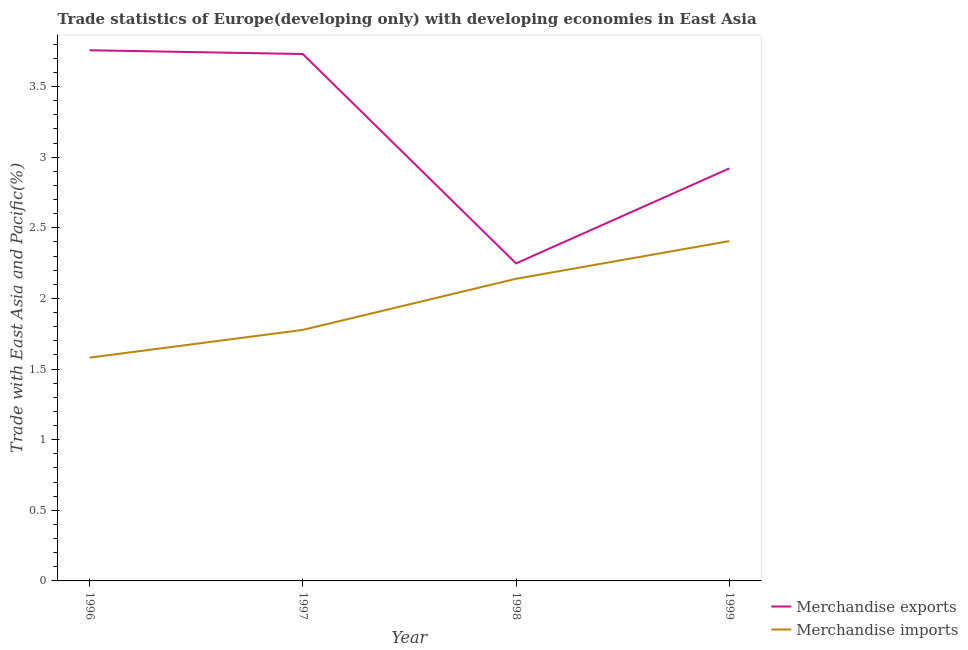Does the line corresponding to merchandise imports intersect with the line corresponding to merchandise exports?
Your answer should be compact. No. Is the number of lines equal to the number of legend labels?
Offer a very short reply. Yes. What is the merchandise exports in 1996?
Make the answer very short. 3.76. Across all years, what is the maximum merchandise exports?
Provide a succinct answer. 3.76. Across all years, what is the minimum merchandise imports?
Give a very brief answer. 1.58. In which year was the merchandise imports minimum?
Offer a very short reply. 1996. What is the total merchandise imports in the graph?
Make the answer very short. 7.9. What is the difference between the merchandise exports in 1998 and that in 1999?
Make the answer very short. -0.67. What is the difference between the merchandise imports in 1999 and the merchandise exports in 1996?
Offer a very short reply. -1.35. What is the average merchandise imports per year?
Give a very brief answer. 1.98. In the year 1996, what is the difference between the merchandise exports and merchandise imports?
Ensure brevity in your answer.  2.18. What is the ratio of the merchandise exports in 1996 to that in 1997?
Your response must be concise. 1.01. Is the merchandise imports in 1996 less than that in 1998?
Provide a succinct answer. Yes. Is the difference between the merchandise exports in 1996 and 1999 greater than the difference between the merchandise imports in 1996 and 1999?
Your answer should be compact. Yes. What is the difference between the highest and the second highest merchandise imports?
Your response must be concise. 0.27. What is the difference between the highest and the lowest merchandise exports?
Provide a succinct answer. 1.51. Does the merchandise exports monotonically increase over the years?
Offer a terse response. No. What is the difference between two consecutive major ticks on the Y-axis?
Make the answer very short. 0.5. Does the graph contain any zero values?
Make the answer very short. No. Does the graph contain grids?
Your answer should be very brief. No. Where does the legend appear in the graph?
Offer a terse response. Bottom right. How are the legend labels stacked?
Keep it short and to the point. Vertical. What is the title of the graph?
Offer a very short reply. Trade statistics of Europe(developing only) with developing economies in East Asia. What is the label or title of the X-axis?
Offer a terse response. Year. What is the label or title of the Y-axis?
Your response must be concise. Trade with East Asia and Pacific(%). What is the Trade with East Asia and Pacific(%) in Merchandise exports in 1996?
Your response must be concise. 3.76. What is the Trade with East Asia and Pacific(%) in Merchandise imports in 1996?
Provide a short and direct response. 1.58. What is the Trade with East Asia and Pacific(%) in Merchandise exports in 1997?
Ensure brevity in your answer.  3.73. What is the Trade with East Asia and Pacific(%) of Merchandise imports in 1997?
Your response must be concise. 1.78. What is the Trade with East Asia and Pacific(%) of Merchandise exports in 1998?
Offer a terse response. 2.25. What is the Trade with East Asia and Pacific(%) in Merchandise imports in 1998?
Provide a succinct answer. 2.14. What is the Trade with East Asia and Pacific(%) in Merchandise exports in 1999?
Offer a very short reply. 2.92. What is the Trade with East Asia and Pacific(%) of Merchandise imports in 1999?
Give a very brief answer. 2.41. Across all years, what is the maximum Trade with East Asia and Pacific(%) of Merchandise exports?
Provide a short and direct response. 3.76. Across all years, what is the maximum Trade with East Asia and Pacific(%) of Merchandise imports?
Give a very brief answer. 2.41. Across all years, what is the minimum Trade with East Asia and Pacific(%) of Merchandise exports?
Ensure brevity in your answer.  2.25. Across all years, what is the minimum Trade with East Asia and Pacific(%) in Merchandise imports?
Make the answer very short. 1.58. What is the total Trade with East Asia and Pacific(%) of Merchandise exports in the graph?
Ensure brevity in your answer.  12.66. What is the total Trade with East Asia and Pacific(%) in Merchandise imports in the graph?
Offer a terse response. 7.9. What is the difference between the Trade with East Asia and Pacific(%) in Merchandise exports in 1996 and that in 1997?
Your answer should be very brief. 0.03. What is the difference between the Trade with East Asia and Pacific(%) of Merchandise imports in 1996 and that in 1997?
Provide a succinct answer. -0.2. What is the difference between the Trade with East Asia and Pacific(%) of Merchandise exports in 1996 and that in 1998?
Keep it short and to the point. 1.51. What is the difference between the Trade with East Asia and Pacific(%) of Merchandise imports in 1996 and that in 1998?
Give a very brief answer. -0.56. What is the difference between the Trade with East Asia and Pacific(%) in Merchandise exports in 1996 and that in 1999?
Provide a short and direct response. 0.84. What is the difference between the Trade with East Asia and Pacific(%) in Merchandise imports in 1996 and that in 1999?
Offer a terse response. -0.83. What is the difference between the Trade with East Asia and Pacific(%) in Merchandise exports in 1997 and that in 1998?
Offer a terse response. 1.48. What is the difference between the Trade with East Asia and Pacific(%) of Merchandise imports in 1997 and that in 1998?
Provide a short and direct response. -0.36. What is the difference between the Trade with East Asia and Pacific(%) of Merchandise exports in 1997 and that in 1999?
Give a very brief answer. 0.81. What is the difference between the Trade with East Asia and Pacific(%) of Merchandise imports in 1997 and that in 1999?
Offer a terse response. -0.63. What is the difference between the Trade with East Asia and Pacific(%) of Merchandise exports in 1998 and that in 1999?
Ensure brevity in your answer.  -0.67. What is the difference between the Trade with East Asia and Pacific(%) of Merchandise imports in 1998 and that in 1999?
Provide a succinct answer. -0.27. What is the difference between the Trade with East Asia and Pacific(%) of Merchandise exports in 1996 and the Trade with East Asia and Pacific(%) of Merchandise imports in 1997?
Give a very brief answer. 1.98. What is the difference between the Trade with East Asia and Pacific(%) of Merchandise exports in 1996 and the Trade with East Asia and Pacific(%) of Merchandise imports in 1998?
Ensure brevity in your answer.  1.62. What is the difference between the Trade with East Asia and Pacific(%) in Merchandise exports in 1996 and the Trade with East Asia and Pacific(%) in Merchandise imports in 1999?
Your answer should be compact. 1.35. What is the difference between the Trade with East Asia and Pacific(%) of Merchandise exports in 1997 and the Trade with East Asia and Pacific(%) of Merchandise imports in 1998?
Make the answer very short. 1.59. What is the difference between the Trade with East Asia and Pacific(%) in Merchandise exports in 1997 and the Trade with East Asia and Pacific(%) in Merchandise imports in 1999?
Your answer should be very brief. 1.32. What is the difference between the Trade with East Asia and Pacific(%) in Merchandise exports in 1998 and the Trade with East Asia and Pacific(%) in Merchandise imports in 1999?
Make the answer very short. -0.16. What is the average Trade with East Asia and Pacific(%) of Merchandise exports per year?
Give a very brief answer. 3.16. What is the average Trade with East Asia and Pacific(%) of Merchandise imports per year?
Your answer should be very brief. 1.98. In the year 1996, what is the difference between the Trade with East Asia and Pacific(%) of Merchandise exports and Trade with East Asia and Pacific(%) of Merchandise imports?
Your answer should be very brief. 2.18. In the year 1997, what is the difference between the Trade with East Asia and Pacific(%) of Merchandise exports and Trade with East Asia and Pacific(%) of Merchandise imports?
Provide a short and direct response. 1.95. In the year 1998, what is the difference between the Trade with East Asia and Pacific(%) of Merchandise exports and Trade with East Asia and Pacific(%) of Merchandise imports?
Provide a succinct answer. 0.11. In the year 1999, what is the difference between the Trade with East Asia and Pacific(%) of Merchandise exports and Trade with East Asia and Pacific(%) of Merchandise imports?
Provide a succinct answer. 0.51. What is the ratio of the Trade with East Asia and Pacific(%) of Merchandise exports in 1996 to that in 1997?
Your answer should be very brief. 1.01. What is the ratio of the Trade with East Asia and Pacific(%) in Merchandise imports in 1996 to that in 1997?
Your answer should be compact. 0.89. What is the ratio of the Trade with East Asia and Pacific(%) of Merchandise exports in 1996 to that in 1998?
Provide a short and direct response. 1.67. What is the ratio of the Trade with East Asia and Pacific(%) in Merchandise imports in 1996 to that in 1998?
Offer a terse response. 0.74. What is the ratio of the Trade with East Asia and Pacific(%) in Merchandise exports in 1996 to that in 1999?
Provide a succinct answer. 1.29. What is the ratio of the Trade with East Asia and Pacific(%) of Merchandise imports in 1996 to that in 1999?
Keep it short and to the point. 0.66. What is the ratio of the Trade with East Asia and Pacific(%) of Merchandise exports in 1997 to that in 1998?
Offer a very short reply. 1.66. What is the ratio of the Trade with East Asia and Pacific(%) in Merchandise imports in 1997 to that in 1998?
Provide a short and direct response. 0.83. What is the ratio of the Trade with East Asia and Pacific(%) in Merchandise exports in 1997 to that in 1999?
Your response must be concise. 1.28. What is the ratio of the Trade with East Asia and Pacific(%) in Merchandise imports in 1997 to that in 1999?
Provide a short and direct response. 0.74. What is the ratio of the Trade with East Asia and Pacific(%) of Merchandise exports in 1998 to that in 1999?
Your answer should be compact. 0.77. What is the ratio of the Trade with East Asia and Pacific(%) of Merchandise imports in 1998 to that in 1999?
Offer a very short reply. 0.89. What is the difference between the highest and the second highest Trade with East Asia and Pacific(%) in Merchandise exports?
Ensure brevity in your answer.  0.03. What is the difference between the highest and the second highest Trade with East Asia and Pacific(%) of Merchandise imports?
Provide a succinct answer. 0.27. What is the difference between the highest and the lowest Trade with East Asia and Pacific(%) of Merchandise exports?
Your answer should be compact. 1.51. What is the difference between the highest and the lowest Trade with East Asia and Pacific(%) in Merchandise imports?
Offer a very short reply. 0.83. 